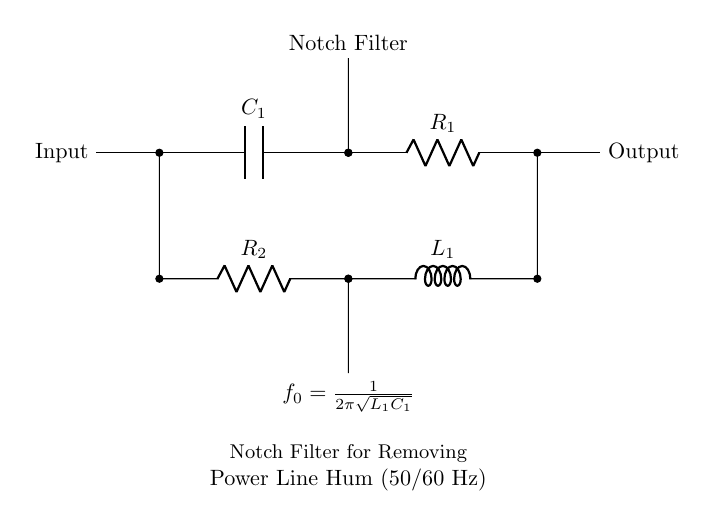What is the type of filter implemented in this circuit? The circuit diagram represents a notch filter, which is specifically designed to attenuate a narrow band of frequencies, thereby removing unwanted signals like power line hum.
Answer: Notch filter What are the values of the components marked in the circuit? The circuit includes one capacitor labeled C1, one resistor labeled R1, one resistor labeled R2, and one inductor labeled L1. Their specific values aren't provided in the diagram, but they are essential in determining the filter's characteristics.
Answer: C1, R1, R2, L1 What is the cutoff frequency formula depicted in the circuit? The formula shown in the diagram for the notch frequency is f0 = 1 divided by 2π times the square root of L1C1. This indicates how the values of the inductor and capacitor influence the filter's frequency response.
Answer: f0 = 1/2π√(L1C1) Which component directly connects the input to the output? The capacitor C1 connects the input directly to the output through another component (the resistor R1), indicating that it passes AC signals while blocking DC.
Answer: C1 What is the purpose of R2 in the circuit? R2 is part of the lower path in the circuit that shunts signals to ground, helping to attenuate frequencies at the notch frequency, thereby enhancing noise rejection in that specific range.
Answer: Attenuation How does this configuration influence the performance at power line frequencies? The components R1, C1, and L1 are specifically chosen to create a notch at either 50 or 60 Hz, which are typical power line frequencies, thus optimizing performance by diminishing this noise while allowing other frequencies to pass.
Answer: Diminishes power line noise What occurs when the frequency of the input signal matches f0? When the input frequency corresponds to f0, the circuit presents a high impedance, effectively preventing that frequency from passing through to the output while maintaining other frequencies, thus achieving its notch filtering effect.
Answer: High impedance 